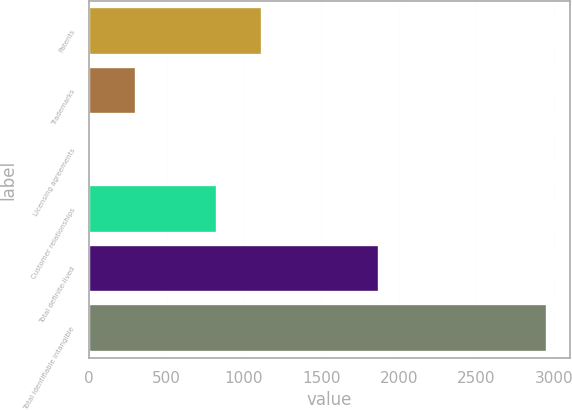Convert chart to OTSL. <chart><loc_0><loc_0><loc_500><loc_500><bar_chart><fcel>Patents<fcel>Trademarks<fcel>Licensing agreements<fcel>Customer relationships<fcel>Total definite-lived<fcel>Total identifiable intangible<nl><fcel>1118.68<fcel>301.88<fcel>6.8<fcel>823.6<fcel>1869.2<fcel>2957.6<nl></chart> 